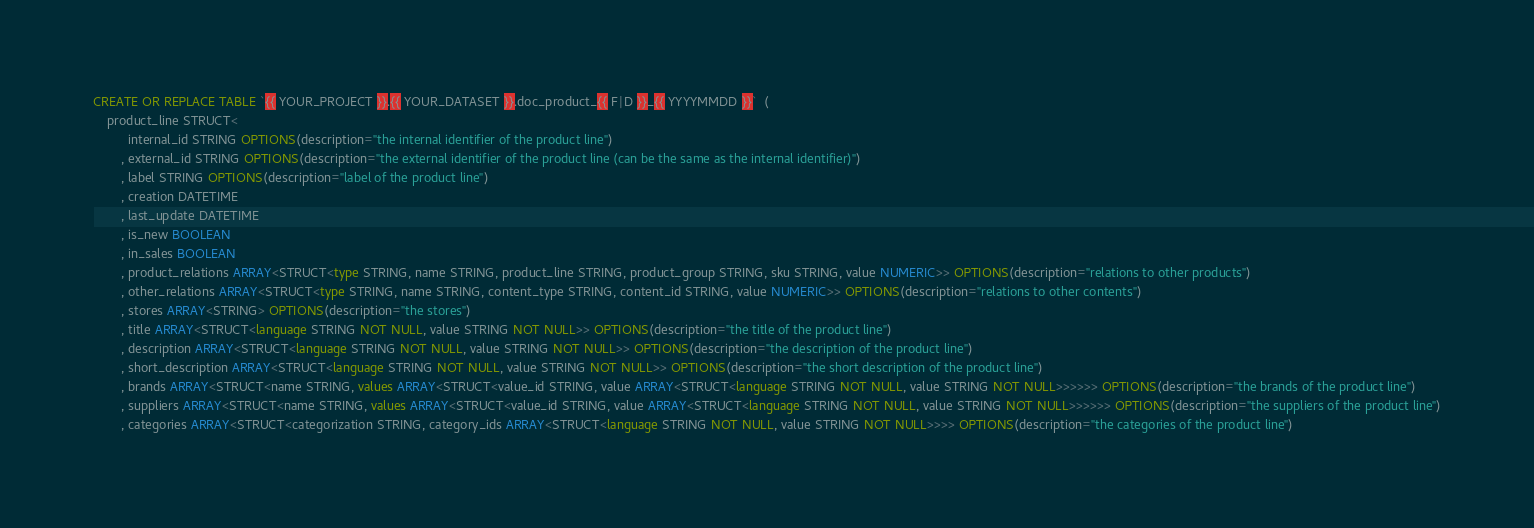<code> <loc_0><loc_0><loc_500><loc_500><_SQL_>CREATE OR REPLACE TABLE `{{ YOUR_PROJECT }}.{{ YOUR_DATASET }}.doc_product_{{ F|D }}_{{ YYYYMMDD }}`  (
	product_line STRUCT<
		  internal_id STRING OPTIONS(description="the internal identifier of the product line")
		, external_id STRING OPTIONS(description="the external identifier of the product line (can be the same as the internal identifier)")
		, label STRING OPTIONS(description="label of the product line")
		, creation DATETIME
		, last_update DATETIME
		, is_new BOOLEAN
		, in_sales BOOLEAN
		, product_relations ARRAY<STRUCT<type STRING, name STRING, product_line STRING, product_group STRING, sku STRING, value NUMERIC>> OPTIONS(description="relations to other products")
		, other_relations ARRAY<STRUCT<type STRING, name STRING, content_type STRING, content_id STRING, value NUMERIC>> OPTIONS(description="relations to other contents")
		, stores ARRAY<STRING> OPTIONS(description="the stores")
		, title ARRAY<STRUCT<language STRING NOT NULL, value STRING NOT NULL>> OPTIONS(description="the title of the product line")
		, description ARRAY<STRUCT<language STRING NOT NULL, value STRING NOT NULL>> OPTIONS(description="the description of the product line")
		, short_description ARRAY<STRUCT<language STRING NOT NULL, value STRING NOT NULL>> OPTIONS(description="the short description of the product line")
		, brands ARRAY<STRUCT<name STRING, values ARRAY<STRUCT<value_id STRING, value ARRAY<STRUCT<language STRING NOT NULL, value STRING NOT NULL>>>>>> OPTIONS(description="the brands of the product line")
		, suppliers ARRAY<STRUCT<name STRING, values ARRAY<STRUCT<value_id STRING, value ARRAY<STRUCT<language STRING NOT NULL, value STRING NOT NULL>>>>>> OPTIONS(description="the suppliers of the product line")
		, categories ARRAY<STRUCT<categorization STRING, category_ids ARRAY<STRUCT<language STRING NOT NULL, value STRING NOT NULL>>>> OPTIONS(description="the categories of the product line")</code> 